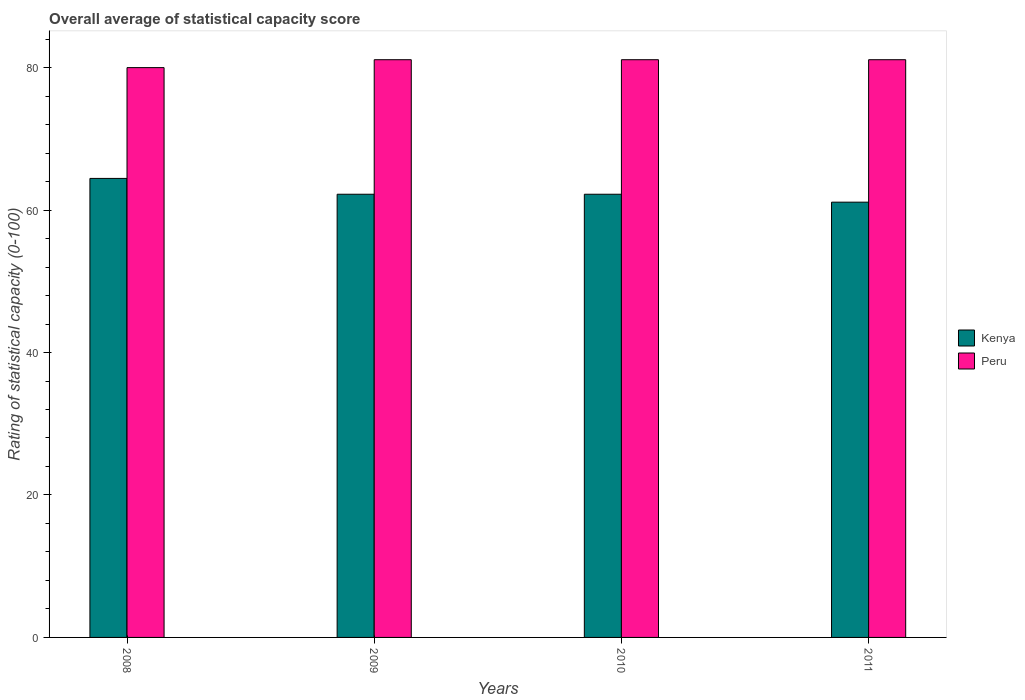How many different coloured bars are there?
Provide a succinct answer. 2. Are the number of bars per tick equal to the number of legend labels?
Offer a terse response. Yes. Are the number of bars on each tick of the X-axis equal?
Provide a succinct answer. Yes. What is the label of the 2nd group of bars from the left?
Give a very brief answer. 2009. In how many cases, is the number of bars for a given year not equal to the number of legend labels?
Offer a terse response. 0. Across all years, what is the maximum rating of statistical capacity in Peru?
Offer a very short reply. 81.11. What is the total rating of statistical capacity in Kenya in the graph?
Your answer should be very brief. 250. What is the difference between the rating of statistical capacity in Kenya in 2008 and that in 2011?
Ensure brevity in your answer.  3.33. What is the difference between the rating of statistical capacity in Kenya in 2008 and the rating of statistical capacity in Peru in 2010?
Make the answer very short. -16.67. What is the average rating of statistical capacity in Kenya per year?
Your answer should be very brief. 62.5. In the year 2010, what is the difference between the rating of statistical capacity in Peru and rating of statistical capacity in Kenya?
Your answer should be very brief. 18.89. What is the ratio of the rating of statistical capacity in Kenya in 2008 to that in 2011?
Offer a very short reply. 1.05. Is the rating of statistical capacity in Kenya in 2009 less than that in 2011?
Ensure brevity in your answer.  No. What is the difference between the highest and the second highest rating of statistical capacity in Kenya?
Offer a very short reply. 2.22. What is the difference between the highest and the lowest rating of statistical capacity in Peru?
Keep it short and to the point. 1.11. Is the sum of the rating of statistical capacity in Kenya in 2008 and 2011 greater than the maximum rating of statistical capacity in Peru across all years?
Ensure brevity in your answer.  Yes. What does the 1st bar from the left in 2011 represents?
Offer a terse response. Kenya. What does the 2nd bar from the right in 2010 represents?
Your answer should be very brief. Kenya. Are all the bars in the graph horizontal?
Ensure brevity in your answer.  No. What is the difference between two consecutive major ticks on the Y-axis?
Your answer should be very brief. 20. Are the values on the major ticks of Y-axis written in scientific E-notation?
Ensure brevity in your answer.  No. Does the graph contain any zero values?
Your answer should be compact. No. Does the graph contain grids?
Offer a terse response. No. How are the legend labels stacked?
Offer a terse response. Vertical. What is the title of the graph?
Give a very brief answer. Overall average of statistical capacity score. Does "Finland" appear as one of the legend labels in the graph?
Give a very brief answer. No. What is the label or title of the Y-axis?
Make the answer very short. Rating of statistical capacity (0-100). What is the Rating of statistical capacity (0-100) of Kenya in 2008?
Make the answer very short. 64.44. What is the Rating of statistical capacity (0-100) of Kenya in 2009?
Your answer should be very brief. 62.22. What is the Rating of statistical capacity (0-100) of Peru in 2009?
Provide a short and direct response. 81.11. What is the Rating of statistical capacity (0-100) in Kenya in 2010?
Provide a short and direct response. 62.22. What is the Rating of statistical capacity (0-100) of Peru in 2010?
Give a very brief answer. 81.11. What is the Rating of statistical capacity (0-100) in Kenya in 2011?
Provide a succinct answer. 61.11. What is the Rating of statistical capacity (0-100) of Peru in 2011?
Offer a terse response. 81.11. Across all years, what is the maximum Rating of statistical capacity (0-100) of Kenya?
Your response must be concise. 64.44. Across all years, what is the maximum Rating of statistical capacity (0-100) of Peru?
Provide a short and direct response. 81.11. Across all years, what is the minimum Rating of statistical capacity (0-100) of Kenya?
Provide a succinct answer. 61.11. What is the total Rating of statistical capacity (0-100) in Kenya in the graph?
Provide a short and direct response. 250. What is the total Rating of statistical capacity (0-100) in Peru in the graph?
Offer a very short reply. 323.33. What is the difference between the Rating of statistical capacity (0-100) in Kenya in 2008 and that in 2009?
Your answer should be compact. 2.22. What is the difference between the Rating of statistical capacity (0-100) of Peru in 2008 and that in 2009?
Your answer should be compact. -1.11. What is the difference between the Rating of statistical capacity (0-100) in Kenya in 2008 and that in 2010?
Your answer should be very brief. 2.22. What is the difference between the Rating of statistical capacity (0-100) in Peru in 2008 and that in 2010?
Your answer should be compact. -1.11. What is the difference between the Rating of statistical capacity (0-100) in Kenya in 2008 and that in 2011?
Provide a succinct answer. 3.33. What is the difference between the Rating of statistical capacity (0-100) of Peru in 2008 and that in 2011?
Offer a terse response. -1.11. What is the difference between the Rating of statistical capacity (0-100) in Kenya in 2009 and that in 2010?
Offer a terse response. 0. What is the difference between the Rating of statistical capacity (0-100) of Kenya in 2009 and that in 2011?
Ensure brevity in your answer.  1.11. What is the difference between the Rating of statistical capacity (0-100) of Kenya in 2010 and that in 2011?
Provide a short and direct response. 1.11. What is the difference between the Rating of statistical capacity (0-100) in Kenya in 2008 and the Rating of statistical capacity (0-100) in Peru in 2009?
Your answer should be very brief. -16.67. What is the difference between the Rating of statistical capacity (0-100) in Kenya in 2008 and the Rating of statistical capacity (0-100) in Peru in 2010?
Your answer should be compact. -16.67. What is the difference between the Rating of statistical capacity (0-100) in Kenya in 2008 and the Rating of statistical capacity (0-100) in Peru in 2011?
Your answer should be very brief. -16.67. What is the difference between the Rating of statistical capacity (0-100) in Kenya in 2009 and the Rating of statistical capacity (0-100) in Peru in 2010?
Ensure brevity in your answer.  -18.89. What is the difference between the Rating of statistical capacity (0-100) of Kenya in 2009 and the Rating of statistical capacity (0-100) of Peru in 2011?
Provide a short and direct response. -18.89. What is the difference between the Rating of statistical capacity (0-100) of Kenya in 2010 and the Rating of statistical capacity (0-100) of Peru in 2011?
Offer a terse response. -18.89. What is the average Rating of statistical capacity (0-100) of Kenya per year?
Your response must be concise. 62.5. What is the average Rating of statistical capacity (0-100) of Peru per year?
Keep it short and to the point. 80.83. In the year 2008, what is the difference between the Rating of statistical capacity (0-100) in Kenya and Rating of statistical capacity (0-100) in Peru?
Provide a succinct answer. -15.56. In the year 2009, what is the difference between the Rating of statistical capacity (0-100) in Kenya and Rating of statistical capacity (0-100) in Peru?
Keep it short and to the point. -18.89. In the year 2010, what is the difference between the Rating of statistical capacity (0-100) of Kenya and Rating of statistical capacity (0-100) of Peru?
Ensure brevity in your answer.  -18.89. What is the ratio of the Rating of statistical capacity (0-100) in Kenya in 2008 to that in 2009?
Provide a short and direct response. 1.04. What is the ratio of the Rating of statistical capacity (0-100) of Peru in 2008 to that in 2009?
Your answer should be compact. 0.99. What is the ratio of the Rating of statistical capacity (0-100) of Kenya in 2008 to that in 2010?
Offer a very short reply. 1.04. What is the ratio of the Rating of statistical capacity (0-100) of Peru in 2008 to that in 2010?
Your answer should be compact. 0.99. What is the ratio of the Rating of statistical capacity (0-100) of Kenya in 2008 to that in 2011?
Offer a very short reply. 1.05. What is the ratio of the Rating of statistical capacity (0-100) in Peru in 2008 to that in 2011?
Your response must be concise. 0.99. What is the ratio of the Rating of statistical capacity (0-100) in Peru in 2009 to that in 2010?
Provide a short and direct response. 1. What is the ratio of the Rating of statistical capacity (0-100) in Kenya in 2009 to that in 2011?
Make the answer very short. 1.02. What is the ratio of the Rating of statistical capacity (0-100) in Kenya in 2010 to that in 2011?
Keep it short and to the point. 1.02. What is the difference between the highest and the second highest Rating of statistical capacity (0-100) in Kenya?
Provide a succinct answer. 2.22. What is the difference between the highest and the lowest Rating of statistical capacity (0-100) in Kenya?
Ensure brevity in your answer.  3.33. What is the difference between the highest and the lowest Rating of statistical capacity (0-100) of Peru?
Make the answer very short. 1.11. 